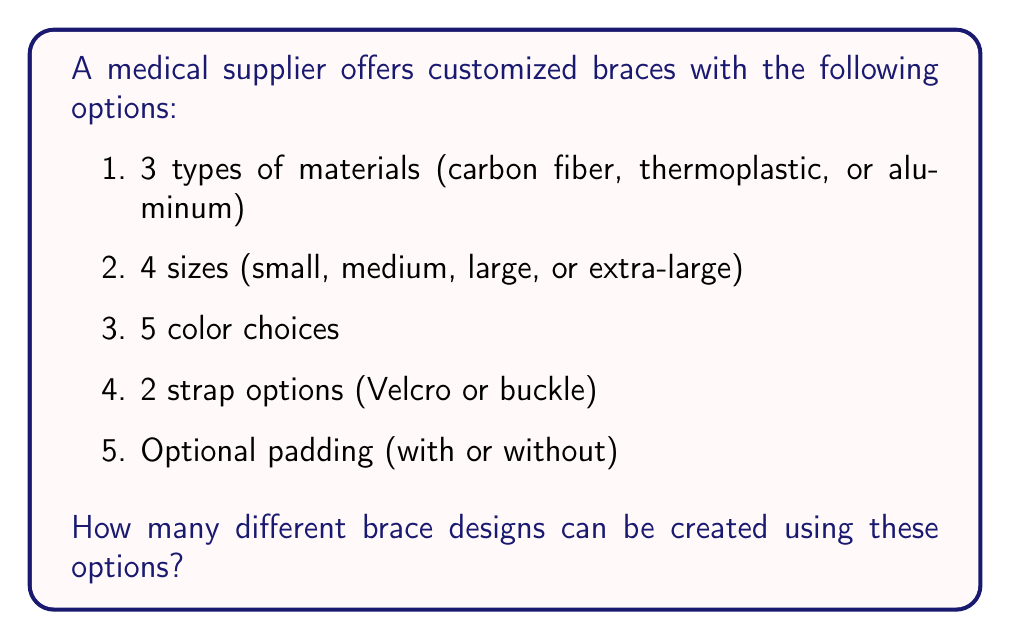What is the answer to this math problem? To solve this problem, we'll use the multiplication principle of counting. This principle states that if we have a sequence of independent choices, the total number of possible outcomes is the product of the number of options for each choice.

Let's break down the choices:
1. Materials: 3 options
2. Sizes: 4 options
3. Colors: 5 options
4. Strap types: 2 options
5. Padding: 2 options (with or without)

Now, we multiply these numbers together:

$$ \text{Total combinations} = 3 \times 4 \times 5 \times 2 \times 2 $$

$$ = 3 \times 4 \times 5 \times 4 $$

$$ = 12 \times 20 $$

$$ = 240 $$

Therefore, the total number of possible brace designs is 240.
Answer: 240 